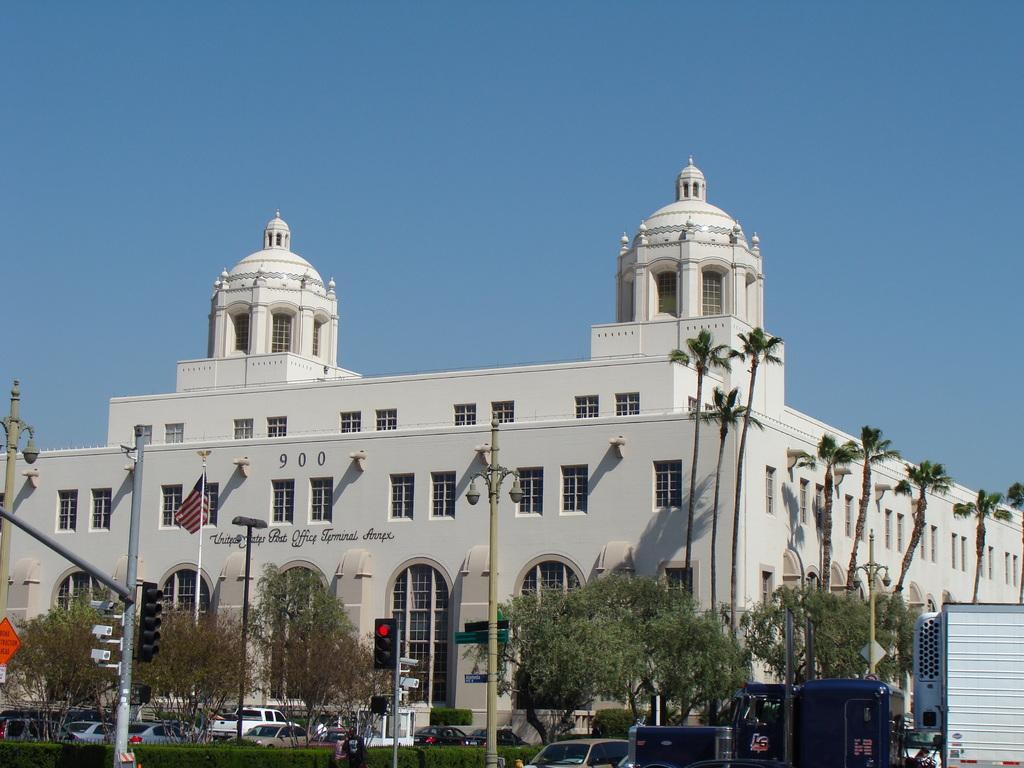Describe this image in one or two sentences. This picture is clicked outside the city. At the bottom of the picture, we see many vehicles moving on the road. We even see traffic signals and street lights. There are trees in the background. Behind that, we see a building in white color. In front of the building, we see a flag which is in red, white and blue color. At the top of the picture, we see the sky, which is blue in color. 